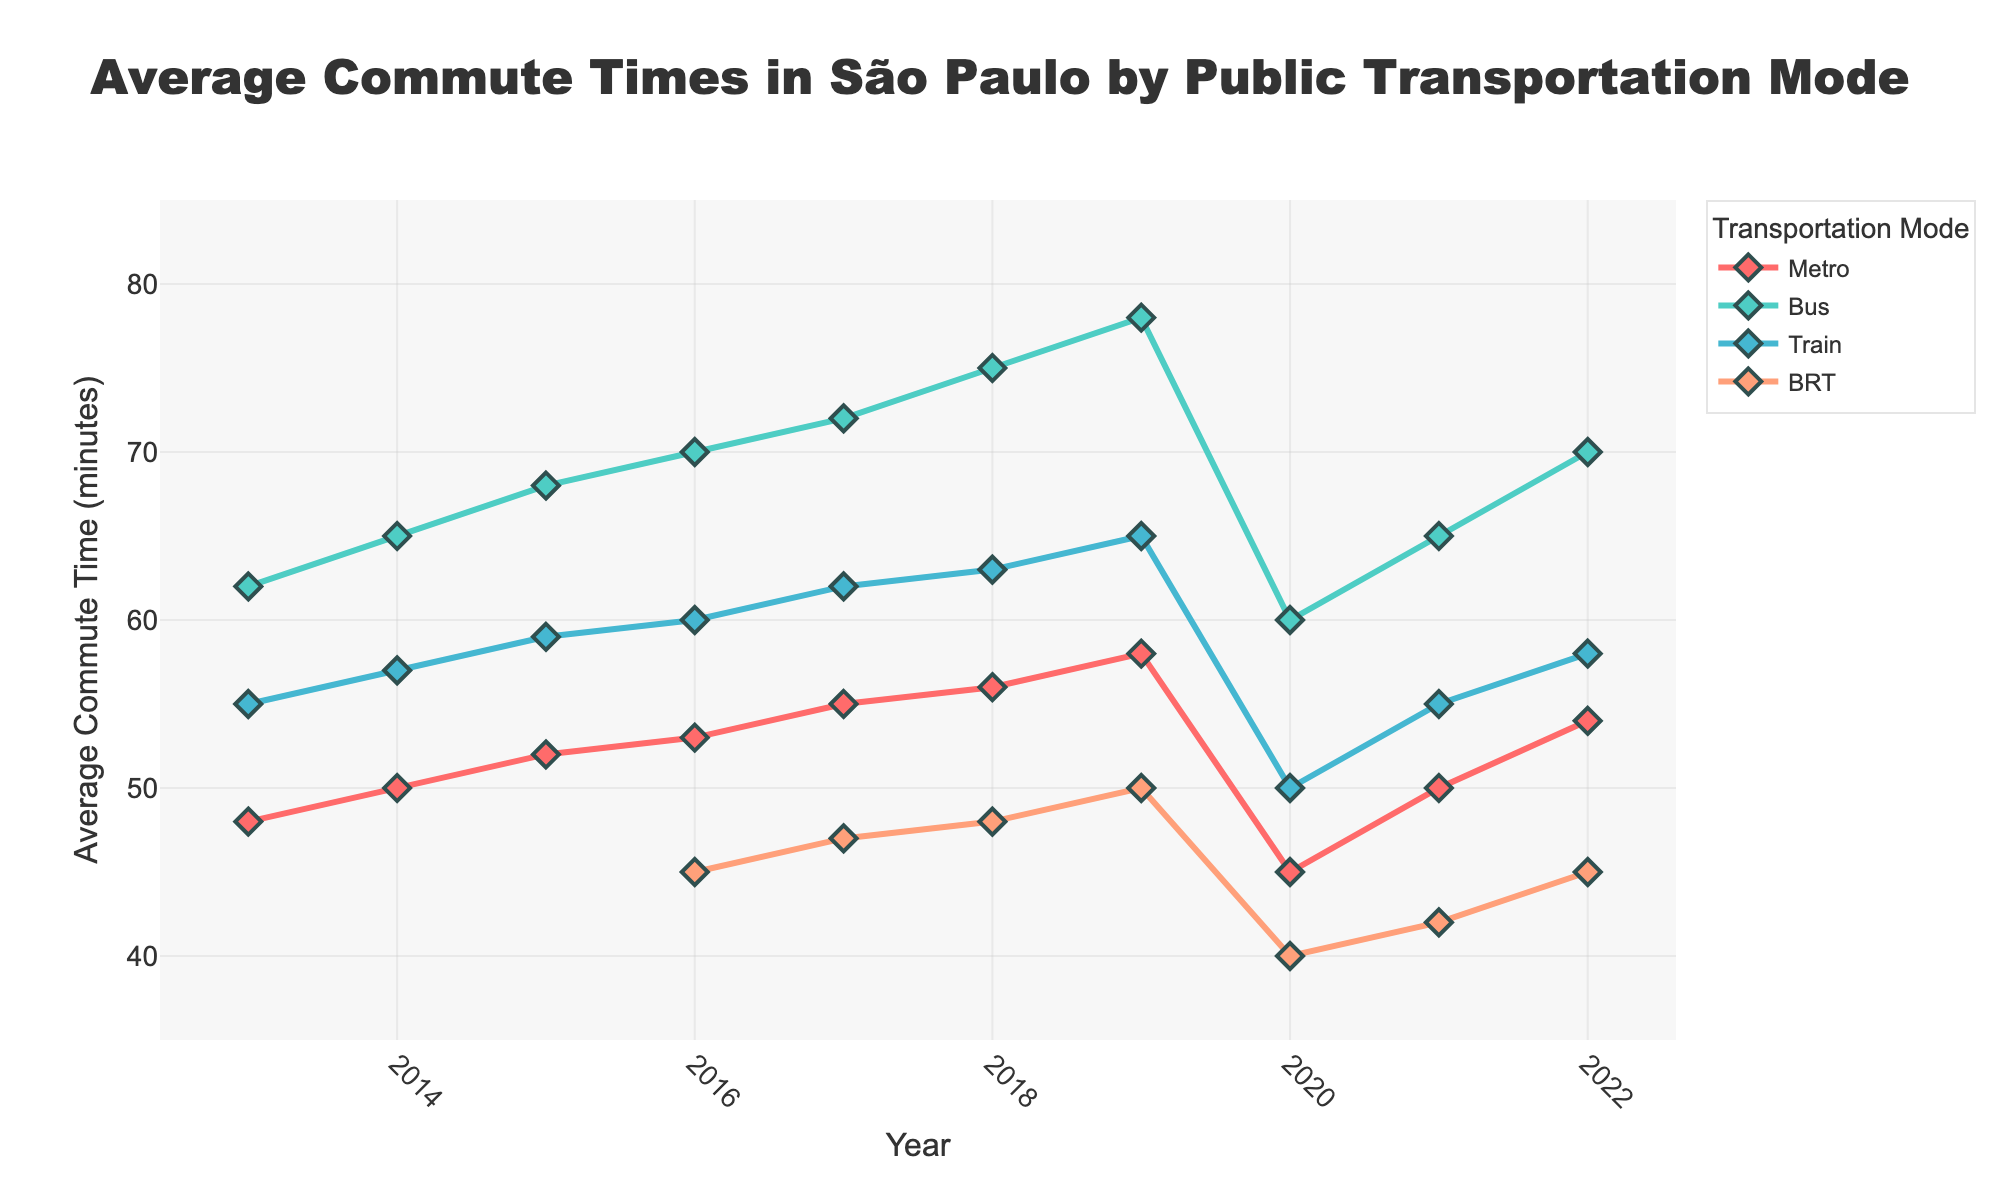What was the average commute time by metro in 2013 and 2022? The line labeled "Metro" shows that the average commute time in 2013 was 48 minutes and in 2022 was 54 minutes.
Answer: 48 minutes in 2013, 54 minutes in 2022 Which transportation mode had the longest average commute time in 2022? By looking at the end points of the lines for each transportation mode in 2022, "Bus" has the highest value at 70 minutes.
Answer: Bus How did the average commute times for BRT change between its introduction in 2016 and 2019? The "BRT" line starts in 2016 at 45 minutes and rises to 50 minutes in 2019. Subtracting 45 from 50 gives an increase of 5 minutes.
Answer: Increased by 5 minutes Which year saw the highest average commute time for trains? The "Train" line peaks in 2019 at 65 minutes, indicating that the highest average commute time occurred that year.
Answer: 2019 Compare the average commute times by bus and metro in 2020. The points for "Bus" and "Metro" in 2020 show 60 and 45 minutes respectively. Comparing these values, the commute by bus is longer.
Answer: Bus is longer Was there any year where BRT had a shorter average commute time than all other modes? In 2020, BRT's average commute time of 40 minutes is shorter than all other modes, making it the only year this occurred.
Answer: 2020 In which years did the average commute time by metro exactly match 50 minutes? The "Metro" line indicates that the average commute time was 50 minutes in 2014 and 2021.
Answer: 2014, 2021 Which transportation mode showed the most significant reduction in average commute time between 2019 and 2020? Observing the downward slope between 2019 and 2020, "Train" decreased from 65 to 50 minutes, a reduction of 15 minutes, which is the largest among all modes.
Answer: Train How does the average commute time by bus in 2013 compare to 2022? From the "Bus" line, the average commute time in 2013 is 62 minutes and in 2022 is 70 minutes. The commute time increased by 8 minutes over the period.
Answer: 8 minutes more in 2022 Calculate the average commute time across all modes for the year 2017. Adding the commute times: Metro (55), Bus (72), Train (62), BRT (47), and dividing by 4 (number of modes) gives an average: (55+72+62+47)/4 = 59 minutes.
Answer: 59 minutes 